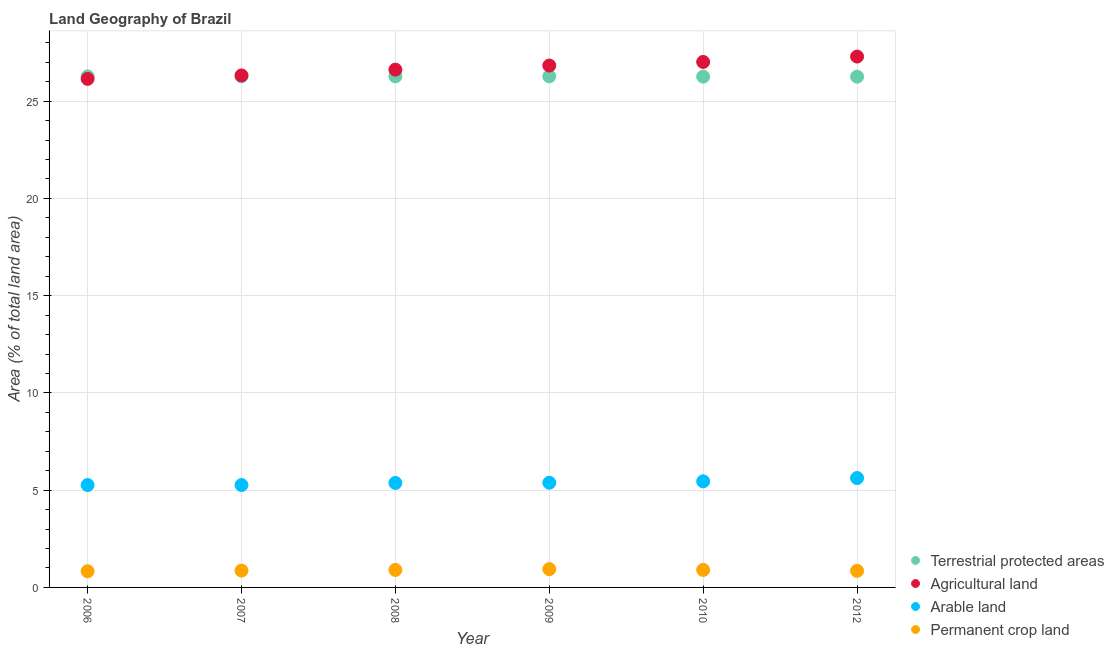How many different coloured dotlines are there?
Your answer should be very brief. 4. Is the number of dotlines equal to the number of legend labels?
Provide a succinct answer. Yes. What is the percentage of area under arable land in 2012?
Give a very brief answer. 5.62. Across all years, what is the maximum percentage of land under terrestrial protection?
Your response must be concise. 26.28. Across all years, what is the minimum percentage of land under terrestrial protection?
Keep it short and to the point. 26.26. What is the total percentage of land under terrestrial protection in the graph?
Offer a very short reply. 157.63. What is the difference between the percentage of area under arable land in 2006 and that in 2010?
Keep it short and to the point. -0.19. What is the difference between the percentage of area under arable land in 2006 and the percentage of area under agricultural land in 2009?
Keep it short and to the point. -21.57. What is the average percentage of land under terrestrial protection per year?
Your answer should be compact. 26.27. In the year 2010, what is the difference between the percentage of area under permanent crop land and percentage of area under agricultural land?
Offer a terse response. -26.12. In how many years, is the percentage of land under terrestrial protection greater than 7 %?
Ensure brevity in your answer.  6. What is the ratio of the percentage of area under arable land in 2007 to that in 2012?
Offer a very short reply. 0.94. Is the percentage of land under terrestrial protection in 2006 less than that in 2009?
Provide a succinct answer. Yes. Is the difference between the percentage of area under agricultural land in 2006 and 2008 greater than the difference between the percentage of area under permanent crop land in 2006 and 2008?
Offer a very short reply. No. What is the difference between the highest and the second highest percentage of area under arable land?
Offer a terse response. 0.17. What is the difference between the highest and the lowest percentage of area under arable land?
Provide a succinct answer. 0.36. In how many years, is the percentage of land under terrestrial protection greater than the average percentage of land under terrestrial protection taken over all years?
Ensure brevity in your answer.  4. Is the percentage of area under arable land strictly greater than the percentage of area under permanent crop land over the years?
Your answer should be very brief. Yes. How many dotlines are there?
Your answer should be compact. 4. How many years are there in the graph?
Make the answer very short. 6. What is the difference between two consecutive major ticks on the Y-axis?
Give a very brief answer. 5. Does the graph contain any zero values?
Your answer should be compact. No. Where does the legend appear in the graph?
Your response must be concise. Bottom right. How are the legend labels stacked?
Offer a very short reply. Vertical. What is the title of the graph?
Your response must be concise. Land Geography of Brazil. Does "Industry" appear as one of the legend labels in the graph?
Your answer should be compact. No. What is the label or title of the X-axis?
Provide a succinct answer. Year. What is the label or title of the Y-axis?
Your answer should be compact. Area (% of total land area). What is the Area (% of total land area) in Terrestrial protected areas in 2006?
Make the answer very short. 26.27. What is the Area (% of total land area) in Agricultural land in 2006?
Your response must be concise. 26.15. What is the Area (% of total land area) of Arable land in 2006?
Provide a succinct answer. 5.26. What is the Area (% of total land area) in Permanent crop land in 2006?
Ensure brevity in your answer.  0.83. What is the Area (% of total land area) in Terrestrial protected areas in 2007?
Your answer should be compact. 26.28. What is the Area (% of total land area) of Agricultural land in 2007?
Give a very brief answer. 26.33. What is the Area (% of total land area) in Arable land in 2007?
Give a very brief answer. 5.26. What is the Area (% of total land area) in Permanent crop land in 2007?
Give a very brief answer. 0.87. What is the Area (% of total land area) in Terrestrial protected areas in 2008?
Provide a short and direct response. 26.28. What is the Area (% of total land area) in Agricultural land in 2008?
Offer a very short reply. 26.62. What is the Area (% of total land area) in Arable land in 2008?
Offer a terse response. 5.37. What is the Area (% of total land area) in Permanent crop land in 2008?
Offer a terse response. 0.9. What is the Area (% of total land area) of Terrestrial protected areas in 2009?
Provide a succinct answer. 26.28. What is the Area (% of total land area) in Agricultural land in 2009?
Ensure brevity in your answer.  26.83. What is the Area (% of total land area) of Arable land in 2009?
Provide a succinct answer. 5.38. What is the Area (% of total land area) in Permanent crop land in 2009?
Make the answer very short. 0.94. What is the Area (% of total land area) in Terrestrial protected areas in 2010?
Give a very brief answer. 26.26. What is the Area (% of total land area) in Agricultural land in 2010?
Your answer should be very brief. 27.02. What is the Area (% of total land area) in Arable land in 2010?
Make the answer very short. 5.46. What is the Area (% of total land area) in Permanent crop land in 2010?
Your answer should be compact. 0.9. What is the Area (% of total land area) of Terrestrial protected areas in 2012?
Your response must be concise. 26.26. What is the Area (% of total land area) of Agricultural land in 2012?
Offer a very short reply. 27.3. What is the Area (% of total land area) in Arable land in 2012?
Make the answer very short. 5.62. What is the Area (% of total land area) in Permanent crop land in 2012?
Offer a very short reply. 0.85. Across all years, what is the maximum Area (% of total land area) in Terrestrial protected areas?
Ensure brevity in your answer.  26.28. Across all years, what is the maximum Area (% of total land area) in Agricultural land?
Ensure brevity in your answer.  27.3. Across all years, what is the maximum Area (% of total land area) of Arable land?
Keep it short and to the point. 5.62. Across all years, what is the maximum Area (% of total land area) in Permanent crop land?
Give a very brief answer. 0.94. Across all years, what is the minimum Area (% of total land area) in Terrestrial protected areas?
Your answer should be compact. 26.26. Across all years, what is the minimum Area (% of total land area) of Agricultural land?
Give a very brief answer. 26.15. Across all years, what is the minimum Area (% of total land area) in Arable land?
Offer a very short reply. 5.26. Across all years, what is the minimum Area (% of total land area) of Permanent crop land?
Offer a terse response. 0.83. What is the total Area (% of total land area) of Terrestrial protected areas in the graph?
Provide a short and direct response. 157.63. What is the total Area (% of total land area) of Agricultural land in the graph?
Keep it short and to the point. 160.24. What is the total Area (% of total land area) of Arable land in the graph?
Offer a very short reply. 32.36. What is the total Area (% of total land area) of Permanent crop land in the graph?
Your answer should be very brief. 5.29. What is the difference between the Area (% of total land area) in Terrestrial protected areas in 2006 and that in 2007?
Ensure brevity in your answer.  -0. What is the difference between the Area (% of total land area) of Agricultural land in 2006 and that in 2007?
Provide a short and direct response. -0.18. What is the difference between the Area (% of total land area) of Permanent crop land in 2006 and that in 2007?
Keep it short and to the point. -0.03. What is the difference between the Area (% of total land area) in Terrestrial protected areas in 2006 and that in 2008?
Keep it short and to the point. -0. What is the difference between the Area (% of total land area) in Agricultural land in 2006 and that in 2008?
Offer a very short reply. -0.47. What is the difference between the Area (% of total land area) of Arable land in 2006 and that in 2008?
Make the answer very short. -0.11. What is the difference between the Area (% of total land area) in Permanent crop land in 2006 and that in 2008?
Your response must be concise. -0.07. What is the difference between the Area (% of total land area) of Terrestrial protected areas in 2006 and that in 2009?
Your answer should be very brief. -0. What is the difference between the Area (% of total land area) in Agricultural land in 2006 and that in 2009?
Your response must be concise. -0.69. What is the difference between the Area (% of total land area) in Arable land in 2006 and that in 2009?
Ensure brevity in your answer.  -0.12. What is the difference between the Area (% of total land area) of Permanent crop land in 2006 and that in 2009?
Your answer should be very brief. -0.11. What is the difference between the Area (% of total land area) of Terrestrial protected areas in 2006 and that in 2010?
Your response must be concise. 0.01. What is the difference between the Area (% of total land area) of Agricultural land in 2006 and that in 2010?
Offer a terse response. -0.87. What is the difference between the Area (% of total land area) in Arable land in 2006 and that in 2010?
Keep it short and to the point. -0.19. What is the difference between the Area (% of total land area) of Permanent crop land in 2006 and that in 2010?
Make the answer very short. -0.07. What is the difference between the Area (% of total land area) of Terrestrial protected areas in 2006 and that in 2012?
Offer a terse response. 0.01. What is the difference between the Area (% of total land area) in Agricultural land in 2006 and that in 2012?
Your response must be concise. -1.15. What is the difference between the Area (% of total land area) of Arable land in 2006 and that in 2012?
Give a very brief answer. -0.36. What is the difference between the Area (% of total land area) of Permanent crop land in 2006 and that in 2012?
Your response must be concise. -0.02. What is the difference between the Area (% of total land area) of Agricultural land in 2007 and that in 2008?
Your response must be concise. -0.3. What is the difference between the Area (% of total land area) in Arable land in 2007 and that in 2008?
Your answer should be compact. -0.11. What is the difference between the Area (% of total land area) of Permanent crop land in 2007 and that in 2008?
Provide a short and direct response. -0.03. What is the difference between the Area (% of total land area) in Agricultural land in 2007 and that in 2009?
Make the answer very short. -0.51. What is the difference between the Area (% of total land area) in Arable land in 2007 and that in 2009?
Your response must be concise. -0.12. What is the difference between the Area (% of total land area) in Permanent crop land in 2007 and that in 2009?
Provide a short and direct response. -0.07. What is the difference between the Area (% of total land area) in Terrestrial protected areas in 2007 and that in 2010?
Give a very brief answer. 0.02. What is the difference between the Area (% of total land area) in Agricultural land in 2007 and that in 2010?
Make the answer very short. -0.69. What is the difference between the Area (% of total land area) in Arable land in 2007 and that in 2010?
Ensure brevity in your answer.  -0.19. What is the difference between the Area (% of total land area) in Permanent crop land in 2007 and that in 2010?
Make the answer very short. -0.03. What is the difference between the Area (% of total land area) of Terrestrial protected areas in 2007 and that in 2012?
Provide a succinct answer. 0.02. What is the difference between the Area (% of total land area) of Agricultural land in 2007 and that in 2012?
Your response must be concise. -0.97. What is the difference between the Area (% of total land area) in Arable land in 2007 and that in 2012?
Offer a terse response. -0.36. What is the difference between the Area (% of total land area) in Permanent crop land in 2007 and that in 2012?
Provide a short and direct response. 0.01. What is the difference between the Area (% of total land area) of Agricultural land in 2008 and that in 2009?
Give a very brief answer. -0.21. What is the difference between the Area (% of total land area) in Arable land in 2008 and that in 2009?
Provide a succinct answer. -0.01. What is the difference between the Area (% of total land area) in Permanent crop land in 2008 and that in 2009?
Make the answer very short. -0.04. What is the difference between the Area (% of total land area) in Terrestrial protected areas in 2008 and that in 2010?
Keep it short and to the point. 0.02. What is the difference between the Area (% of total land area) in Agricultural land in 2008 and that in 2010?
Give a very brief answer. -0.4. What is the difference between the Area (% of total land area) of Arable land in 2008 and that in 2010?
Your response must be concise. -0.08. What is the difference between the Area (% of total land area) of Permanent crop land in 2008 and that in 2010?
Keep it short and to the point. -0. What is the difference between the Area (% of total land area) of Terrestrial protected areas in 2008 and that in 2012?
Provide a succinct answer. 0.02. What is the difference between the Area (% of total land area) in Agricultural land in 2008 and that in 2012?
Your answer should be compact. -0.67. What is the difference between the Area (% of total land area) of Arable land in 2008 and that in 2012?
Ensure brevity in your answer.  -0.25. What is the difference between the Area (% of total land area) in Permanent crop land in 2008 and that in 2012?
Offer a very short reply. 0.05. What is the difference between the Area (% of total land area) of Terrestrial protected areas in 2009 and that in 2010?
Offer a very short reply. 0.02. What is the difference between the Area (% of total land area) in Agricultural land in 2009 and that in 2010?
Keep it short and to the point. -0.18. What is the difference between the Area (% of total land area) of Arable land in 2009 and that in 2010?
Ensure brevity in your answer.  -0.07. What is the difference between the Area (% of total land area) in Permanent crop land in 2009 and that in 2010?
Your response must be concise. 0.04. What is the difference between the Area (% of total land area) of Terrestrial protected areas in 2009 and that in 2012?
Provide a short and direct response. 0.02. What is the difference between the Area (% of total land area) in Agricultural land in 2009 and that in 2012?
Offer a terse response. -0.46. What is the difference between the Area (% of total land area) of Arable land in 2009 and that in 2012?
Your answer should be compact. -0.24. What is the difference between the Area (% of total land area) in Permanent crop land in 2009 and that in 2012?
Offer a terse response. 0.09. What is the difference between the Area (% of total land area) of Terrestrial protected areas in 2010 and that in 2012?
Your answer should be compact. 0. What is the difference between the Area (% of total land area) of Agricultural land in 2010 and that in 2012?
Provide a short and direct response. -0.28. What is the difference between the Area (% of total land area) of Arable land in 2010 and that in 2012?
Give a very brief answer. -0.17. What is the difference between the Area (% of total land area) in Permanent crop land in 2010 and that in 2012?
Keep it short and to the point. 0.05. What is the difference between the Area (% of total land area) of Terrestrial protected areas in 2006 and the Area (% of total land area) of Agricultural land in 2007?
Your answer should be compact. -0.05. What is the difference between the Area (% of total land area) of Terrestrial protected areas in 2006 and the Area (% of total land area) of Arable land in 2007?
Provide a succinct answer. 21.01. What is the difference between the Area (% of total land area) of Terrestrial protected areas in 2006 and the Area (% of total land area) of Permanent crop land in 2007?
Keep it short and to the point. 25.41. What is the difference between the Area (% of total land area) in Agricultural land in 2006 and the Area (% of total land area) in Arable land in 2007?
Make the answer very short. 20.88. What is the difference between the Area (% of total land area) of Agricultural land in 2006 and the Area (% of total land area) of Permanent crop land in 2007?
Your response must be concise. 25.28. What is the difference between the Area (% of total land area) of Arable land in 2006 and the Area (% of total land area) of Permanent crop land in 2007?
Make the answer very short. 4.4. What is the difference between the Area (% of total land area) in Terrestrial protected areas in 2006 and the Area (% of total land area) in Agricultural land in 2008?
Provide a short and direct response. -0.35. What is the difference between the Area (% of total land area) of Terrestrial protected areas in 2006 and the Area (% of total land area) of Arable land in 2008?
Offer a terse response. 20.9. What is the difference between the Area (% of total land area) of Terrestrial protected areas in 2006 and the Area (% of total land area) of Permanent crop land in 2008?
Offer a terse response. 25.38. What is the difference between the Area (% of total land area) of Agricultural land in 2006 and the Area (% of total land area) of Arable land in 2008?
Provide a succinct answer. 20.78. What is the difference between the Area (% of total land area) of Agricultural land in 2006 and the Area (% of total land area) of Permanent crop land in 2008?
Your response must be concise. 25.25. What is the difference between the Area (% of total land area) of Arable land in 2006 and the Area (% of total land area) of Permanent crop land in 2008?
Ensure brevity in your answer.  4.37. What is the difference between the Area (% of total land area) of Terrestrial protected areas in 2006 and the Area (% of total land area) of Agricultural land in 2009?
Keep it short and to the point. -0.56. What is the difference between the Area (% of total land area) of Terrestrial protected areas in 2006 and the Area (% of total land area) of Arable land in 2009?
Make the answer very short. 20.89. What is the difference between the Area (% of total land area) of Terrestrial protected areas in 2006 and the Area (% of total land area) of Permanent crop land in 2009?
Offer a terse response. 25.33. What is the difference between the Area (% of total land area) of Agricultural land in 2006 and the Area (% of total land area) of Arable land in 2009?
Make the answer very short. 20.76. What is the difference between the Area (% of total land area) of Agricultural land in 2006 and the Area (% of total land area) of Permanent crop land in 2009?
Give a very brief answer. 25.21. What is the difference between the Area (% of total land area) in Arable land in 2006 and the Area (% of total land area) in Permanent crop land in 2009?
Offer a terse response. 4.32. What is the difference between the Area (% of total land area) in Terrestrial protected areas in 2006 and the Area (% of total land area) in Agricultural land in 2010?
Offer a terse response. -0.74. What is the difference between the Area (% of total land area) in Terrestrial protected areas in 2006 and the Area (% of total land area) in Arable land in 2010?
Give a very brief answer. 20.82. What is the difference between the Area (% of total land area) of Terrestrial protected areas in 2006 and the Area (% of total land area) of Permanent crop land in 2010?
Offer a very short reply. 25.37. What is the difference between the Area (% of total land area) in Agricultural land in 2006 and the Area (% of total land area) in Arable land in 2010?
Make the answer very short. 20.69. What is the difference between the Area (% of total land area) of Agricultural land in 2006 and the Area (% of total land area) of Permanent crop land in 2010?
Your response must be concise. 25.25. What is the difference between the Area (% of total land area) of Arable land in 2006 and the Area (% of total land area) of Permanent crop land in 2010?
Keep it short and to the point. 4.36. What is the difference between the Area (% of total land area) in Terrestrial protected areas in 2006 and the Area (% of total land area) in Agricultural land in 2012?
Your answer should be compact. -1.02. What is the difference between the Area (% of total land area) of Terrestrial protected areas in 2006 and the Area (% of total land area) of Arable land in 2012?
Offer a very short reply. 20.65. What is the difference between the Area (% of total land area) in Terrestrial protected areas in 2006 and the Area (% of total land area) in Permanent crop land in 2012?
Ensure brevity in your answer.  25.42. What is the difference between the Area (% of total land area) of Agricultural land in 2006 and the Area (% of total land area) of Arable land in 2012?
Ensure brevity in your answer.  20.52. What is the difference between the Area (% of total land area) of Agricultural land in 2006 and the Area (% of total land area) of Permanent crop land in 2012?
Make the answer very short. 25.29. What is the difference between the Area (% of total land area) in Arable land in 2006 and the Area (% of total land area) in Permanent crop land in 2012?
Keep it short and to the point. 4.41. What is the difference between the Area (% of total land area) of Terrestrial protected areas in 2007 and the Area (% of total land area) of Agricultural land in 2008?
Make the answer very short. -0.34. What is the difference between the Area (% of total land area) of Terrestrial protected areas in 2007 and the Area (% of total land area) of Arable land in 2008?
Provide a short and direct response. 20.91. What is the difference between the Area (% of total land area) in Terrestrial protected areas in 2007 and the Area (% of total land area) in Permanent crop land in 2008?
Keep it short and to the point. 25.38. What is the difference between the Area (% of total land area) in Agricultural land in 2007 and the Area (% of total land area) in Arable land in 2008?
Ensure brevity in your answer.  20.95. What is the difference between the Area (% of total land area) of Agricultural land in 2007 and the Area (% of total land area) of Permanent crop land in 2008?
Provide a short and direct response. 25.43. What is the difference between the Area (% of total land area) in Arable land in 2007 and the Area (% of total land area) in Permanent crop land in 2008?
Your answer should be very brief. 4.37. What is the difference between the Area (% of total land area) of Terrestrial protected areas in 2007 and the Area (% of total land area) of Agricultural land in 2009?
Provide a succinct answer. -0.56. What is the difference between the Area (% of total land area) in Terrestrial protected areas in 2007 and the Area (% of total land area) in Arable land in 2009?
Your answer should be very brief. 20.89. What is the difference between the Area (% of total land area) in Terrestrial protected areas in 2007 and the Area (% of total land area) in Permanent crop land in 2009?
Ensure brevity in your answer.  25.34. What is the difference between the Area (% of total land area) in Agricultural land in 2007 and the Area (% of total land area) in Arable land in 2009?
Provide a short and direct response. 20.94. What is the difference between the Area (% of total land area) in Agricultural land in 2007 and the Area (% of total land area) in Permanent crop land in 2009?
Provide a succinct answer. 25.39. What is the difference between the Area (% of total land area) of Arable land in 2007 and the Area (% of total land area) of Permanent crop land in 2009?
Your answer should be compact. 4.32. What is the difference between the Area (% of total land area) of Terrestrial protected areas in 2007 and the Area (% of total land area) of Agricultural land in 2010?
Your response must be concise. -0.74. What is the difference between the Area (% of total land area) of Terrestrial protected areas in 2007 and the Area (% of total land area) of Arable land in 2010?
Make the answer very short. 20.82. What is the difference between the Area (% of total land area) of Terrestrial protected areas in 2007 and the Area (% of total land area) of Permanent crop land in 2010?
Provide a succinct answer. 25.38. What is the difference between the Area (% of total land area) of Agricultural land in 2007 and the Area (% of total land area) of Arable land in 2010?
Your answer should be compact. 20.87. What is the difference between the Area (% of total land area) of Agricultural land in 2007 and the Area (% of total land area) of Permanent crop land in 2010?
Ensure brevity in your answer.  25.43. What is the difference between the Area (% of total land area) in Arable land in 2007 and the Area (% of total land area) in Permanent crop land in 2010?
Ensure brevity in your answer.  4.36. What is the difference between the Area (% of total land area) of Terrestrial protected areas in 2007 and the Area (% of total land area) of Agricultural land in 2012?
Offer a terse response. -1.02. What is the difference between the Area (% of total land area) in Terrestrial protected areas in 2007 and the Area (% of total land area) in Arable land in 2012?
Your answer should be very brief. 20.66. What is the difference between the Area (% of total land area) of Terrestrial protected areas in 2007 and the Area (% of total land area) of Permanent crop land in 2012?
Provide a short and direct response. 25.42. What is the difference between the Area (% of total land area) in Agricultural land in 2007 and the Area (% of total land area) in Arable land in 2012?
Your answer should be compact. 20.7. What is the difference between the Area (% of total land area) of Agricultural land in 2007 and the Area (% of total land area) of Permanent crop land in 2012?
Give a very brief answer. 25.47. What is the difference between the Area (% of total land area) of Arable land in 2007 and the Area (% of total land area) of Permanent crop land in 2012?
Offer a terse response. 4.41. What is the difference between the Area (% of total land area) in Terrestrial protected areas in 2008 and the Area (% of total land area) in Agricultural land in 2009?
Offer a very short reply. -0.56. What is the difference between the Area (% of total land area) in Terrestrial protected areas in 2008 and the Area (% of total land area) in Arable land in 2009?
Make the answer very short. 20.89. What is the difference between the Area (% of total land area) of Terrestrial protected areas in 2008 and the Area (% of total land area) of Permanent crop land in 2009?
Your answer should be compact. 25.34. What is the difference between the Area (% of total land area) in Agricultural land in 2008 and the Area (% of total land area) in Arable land in 2009?
Your answer should be compact. 21.24. What is the difference between the Area (% of total land area) in Agricultural land in 2008 and the Area (% of total land area) in Permanent crop land in 2009?
Ensure brevity in your answer.  25.68. What is the difference between the Area (% of total land area) of Arable land in 2008 and the Area (% of total land area) of Permanent crop land in 2009?
Offer a terse response. 4.43. What is the difference between the Area (% of total land area) of Terrestrial protected areas in 2008 and the Area (% of total land area) of Agricultural land in 2010?
Provide a succinct answer. -0.74. What is the difference between the Area (% of total land area) in Terrestrial protected areas in 2008 and the Area (% of total land area) in Arable land in 2010?
Keep it short and to the point. 20.82. What is the difference between the Area (% of total land area) of Terrestrial protected areas in 2008 and the Area (% of total land area) of Permanent crop land in 2010?
Ensure brevity in your answer.  25.38. What is the difference between the Area (% of total land area) in Agricultural land in 2008 and the Area (% of total land area) in Arable land in 2010?
Give a very brief answer. 21.17. What is the difference between the Area (% of total land area) of Agricultural land in 2008 and the Area (% of total land area) of Permanent crop land in 2010?
Your response must be concise. 25.72. What is the difference between the Area (% of total land area) of Arable land in 2008 and the Area (% of total land area) of Permanent crop land in 2010?
Make the answer very short. 4.47. What is the difference between the Area (% of total land area) in Terrestrial protected areas in 2008 and the Area (% of total land area) in Agricultural land in 2012?
Your answer should be very brief. -1.02. What is the difference between the Area (% of total land area) of Terrestrial protected areas in 2008 and the Area (% of total land area) of Arable land in 2012?
Your response must be concise. 20.66. What is the difference between the Area (% of total land area) in Terrestrial protected areas in 2008 and the Area (% of total land area) in Permanent crop land in 2012?
Provide a short and direct response. 25.42. What is the difference between the Area (% of total land area) in Agricultural land in 2008 and the Area (% of total land area) in Arable land in 2012?
Ensure brevity in your answer.  21. What is the difference between the Area (% of total land area) in Agricultural land in 2008 and the Area (% of total land area) in Permanent crop land in 2012?
Provide a short and direct response. 25.77. What is the difference between the Area (% of total land area) in Arable land in 2008 and the Area (% of total land area) in Permanent crop land in 2012?
Offer a terse response. 4.52. What is the difference between the Area (% of total land area) in Terrestrial protected areas in 2009 and the Area (% of total land area) in Agricultural land in 2010?
Your answer should be very brief. -0.74. What is the difference between the Area (% of total land area) of Terrestrial protected areas in 2009 and the Area (% of total land area) of Arable land in 2010?
Make the answer very short. 20.82. What is the difference between the Area (% of total land area) of Terrestrial protected areas in 2009 and the Area (% of total land area) of Permanent crop land in 2010?
Provide a succinct answer. 25.38. What is the difference between the Area (% of total land area) of Agricultural land in 2009 and the Area (% of total land area) of Arable land in 2010?
Give a very brief answer. 21.38. What is the difference between the Area (% of total land area) of Agricultural land in 2009 and the Area (% of total land area) of Permanent crop land in 2010?
Your answer should be very brief. 25.93. What is the difference between the Area (% of total land area) of Arable land in 2009 and the Area (% of total land area) of Permanent crop land in 2010?
Your answer should be compact. 4.48. What is the difference between the Area (% of total land area) in Terrestrial protected areas in 2009 and the Area (% of total land area) in Agricultural land in 2012?
Offer a terse response. -1.02. What is the difference between the Area (% of total land area) in Terrestrial protected areas in 2009 and the Area (% of total land area) in Arable land in 2012?
Your answer should be very brief. 20.66. What is the difference between the Area (% of total land area) in Terrestrial protected areas in 2009 and the Area (% of total land area) in Permanent crop land in 2012?
Provide a short and direct response. 25.42. What is the difference between the Area (% of total land area) of Agricultural land in 2009 and the Area (% of total land area) of Arable land in 2012?
Give a very brief answer. 21.21. What is the difference between the Area (% of total land area) in Agricultural land in 2009 and the Area (% of total land area) in Permanent crop land in 2012?
Offer a terse response. 25.98. What is the difference between the Area (% of total land area) in Arable land in 2009 and the Area (% of total land area) in Permanent crop land in 2012?
Ensure brevity in your answer.  4.53. What is the difference between the Area (% of total land area) in Terrestrial protected areas in 2010 and the Area (% of total land area) in Agricultural land in 2012?
Give a very brief answer. -1.03. What is the difference between the Area (% of total land area) of Terrestrial protected areas in 2010 and the Area (% of total land area) of Arable land in 2012?
Provide a short and direct response. 20.64. What is the difference between the Area (% of total land area) of Terrestrial protected areas in 2010 and the Area (% of total land area) of Permanent crop land in 2012?
Give a very brief answer. 25.41. What is the difference between the Area (% of total land area) of Agricultural land in 2010 and the Area (% of total land area) of Arable land in 2012?
Ensure brevity in your answer.  21.4. What is the difference between the Area (% of total land area) in Agricultural land in 2010 and the Area (% of total land area) in Permanent crop land in 2012?
Provide a short and direct response. 26.16. What is the difference between the Area (% of total land area) in Arable land in 2010 and the Area (% of total land area) in Permanent crop land in 2012?
Your answer should be compact. 4.6. What is the average Area (% of total land area) in Terrestrial protected areas per year?
Provide a succinct answer. 26.27. What is the average Area (% of total land area) of Agricultural land per year?
Make the answer very short. 26.71. What is the average Area (% of total land area) of Arable land per year?
Give a very brief answer. 5.39. What is the average Area (% of total land area) in Permanent crop land per year?
Offer a very short reply. 0.88. In the year 2006, what is the difference between the Area (% of total land area) in Terrestrial protected areas and Area (% of total land area) in Agricultural land?
Make the answer very short. 0.13. In the year 2006, what is the difference between the Area (% of total land area) in Terrestrial protected areas and Area (% of total land area) in Arable land?
Keep it short and to the point. 21.01. In the year 2006, what is the difference between the Area (% of total land area) of Terrestrial protected areas and Area (% of total land area) of Permanent crop land?
Make the answer very short. 25.44. In the year 2006, what is the difference between the Area (% of total land area) in Agricultural land and Area (% of total land area) in Arable land?
Offer a terse response. 20.88. In the year 2006, what is the difference between the Area (% of total land area) of Agricultural land and Area (% of total land area) of Permanent crop land?
Give a very brief answer. 25.32. In the year 2006, what is the difference between the Area (% of total land area) of Arable land and Area (% of total land area) of Permanent crop land?
Make the answer very short. 4.43. In the year 2007, what is the difference between the Area (% of total land area) of Terrestrial protected areas and Area (% of total land area) of Agricultural land?
Keep it short and to the point. -0.05. In the year 2007, what is the difference between the Area (% of total land area) in Terrestrial protected areas and Area (% of total land area) in Arable land?
Your answer should be very brief. 21.01. In the year 2007, what is the difference between the Area (% of total land area) of Terrestrial protected areas and Area (% of total land area) of Permanent crop land?
Offer a very short reply. 25.41. In the year 2007, what is the difference between the Area (% of total land area) in Agricultural land and Area (% of total land area) in Arable land?
Offer a terse response. 21.06. In the year 2007, what is the difference between the Area (% of total land area) of Agricultural land and Area (% of total land area) of Permanent crop land?
Make the answer very short. 25.46. In the year 2007, what is the difference between the Area (% of total land area) in Arable land and Area (% of total land area) in Permanent crop land?
Offer a terse response. 4.4. In the year 2008, what is the difference between the Area (% of total land area) in Terrestrial protected areas and Area (% of total land area) in Agricultural land?
Your response must be concise. -0.34. In the year 2008, what is the difference between the Area (% of total land area) in Terrestrial protected areas and Area (% of total land area) in Arable land?
Your answer should be very brief. 20.91. In the year 2008, what is the difference between the Area (% of total land area) of Terrestrial protected areas and Area (% of total land area) of Permanent crop land?
Your answer should be compact. 25.38. In the year 2008, what is the difference between the Area (% of total land area) of Agricultural land and Area (% of total land area) of Arable land?
Make the answer very short. 21.25. In the year 2008, what is the difference between the Area (% of total land area) in Agricultural land and Area (% of total land area) in Permanent crop land?
Keep it short and to the point. 25.72. In the year 2008, what is the difference between the Area (% of total land area) in Arable land and Area (% of total land area) in Permanent crop land?
Keep it short and to the point. 4.47. In the year 2009, what is the difference between the Area (% of total land area) of Terrestrial protected areas and Area (% of total land area) of Agricultural land?
Make the answer very short. -0.55. In the year 2009, what is the difference between the Area (% of total land area) of Terrestrial protected areas and Area (% of total land area) of Arable land?
Offer a very short reply. 20.89. In the year 2009, what is the difference between the Area (% of total land area) in Terrestrial protected areas and Area (% of total land area) in Permanent crop land?
Provide a short and direct response. 25.34. In the year 2009, what is the difference between the Area (% of total land area) in Agricultural land and Area (% of total land area) in Arable land?
Your response must be concise. 21.45. In the year 2009, what is the difference between the Area (% of total land area) in Agricultural land and Area (% of total land area) in Permanent crop land?
Your answer should be very brief. 25.89. In the year 2009, what is the difference between the Area (% of total land area) in Arable land and Area (% of total land area) in Permanent crop land?
Provide a succinct answer. 4.44. In the year 2010, what is the difference between the Area (% of total land area) in Terrestrial protected areas and Area (% of total land area) in Agricultural land?
Your answer should be compact. -0.76. In the year 2010, what is the difference between the Area (% of total land area) in Terrestrial protected areas and Area (% of total land area) in Arable land?
Provide a succinct answer. 20.81. In the year 2010, what is the difference between the Area (% of total land area) of Terrestrial protected areas and Area (% of total land area) of Permanent crop land?
Your response must be concise. 25.36. In the year 2010, what is the difference between the Area (% of total land area) of Agricultural land and Area (% of total land area) of Arable land?
Your answer should be very brief. 21.56. In the year 2010, what is the difference between the Area (% of total land area) of Agricultural land and Area (% of total land area) of Permanent crop land?
Your response must be concise. 26.12. In the year 2010, what is the difference between the Area (% of total land area) of Arable land and Area (% of total land area) of Permanent crop land?
Offer a very short reply. 4.56. In the year 2012, what is the difference between the Area (% of total land area) of Terrestrial protected areas and Area (% of total land area) of Agricultural land?
Offer a terse response. -1.03. In the year 2012, what is the difference between the Area (% of total land area) in Terrestrial protected areas and Area (% of total land area) in Arable land?
Give a very brief answer. 20.64. In the year 2012, what is the difference between the Area (% of total land area) in Terrestrial protected areas and Area (% of total land area) in Permanent crop land?
Provide a succinct answer. 25.41. In the year 2012, what is the difference between the Area (% of total land area) in Agricultural land and Area (% of total land area) in Arable land?
Your answer should be compact. 21.67. In the year 2012, what is the difference between the Area (% of total land area) in Agricultural land and Area (% of total land area) in Permanent crop land?
Provide a succinct answer. 26.44. In the year 2012, what is the difference between the Area (% of total land area) in Arable land and Area (% of total land area) in Permanent crop land?
Your answer should be very brief. 4.77. What is the ratio of the Area (% of total land area) of Agricultural land in 2006 to that in 2007?
Offer a terse response. 0.99. What is the ratio of the Area (% of total land area) in Arable land in 2006 to that in 2007?
Provide a short and direct response. 1. What is the ratio of the Area (% of total land area) of Permanent crop land in 2006 to that in 2007?
Keep it short and to the point. 0.96. What is the ratio of the Area (% of total land area) of Agricultural land in 2006 to that in 2008?
Your answer should be compact. 0.98. What is the ratio of the Area (% of total land area) in Permanent crop land in 2006 to that in 2008?
Offer a very short reply. 0.93. What is the ratio of the Area (% of total land area) of Terrestrial protected areas in 2006 to that in 2009?
Ensure brevity in your answer.  1. What is the ratio of the Area (% of total land area) of Agricultural land in 2006 to that in 2009?
Provide a succinct answer. 0.97. What is the ratio of the Area (% of total land area) in Arable land in 2006 to that in 2009?
Provide a short and direct response. 0.98. What is the ratio of the Area (% of total land area) in Permanent crop land in 2006 to that in 2009?
Provide a short and direct response. 0.88. What is the ratio of the Area (% of total land area) in Agricultural land in 2006 to that in 2010?
Your answer should be very brief. 0.97. What is the ratio of the Area (% of total land area) in Arable land in 2006 to that in 2010?
Your answer should be compact. 0.96. What is the ratio of the Area (% of total land area) of Permanent crop land in 2006 to that in 2010?
Offer a very short reply. 0.92. What is the ratio of the Area (% of total land area) of Terrestrial protected areas in 2006 to that in 2012?
Give a very brief answer. 1. What is the ratio of the Area (% of total land area) of Agricultural land in 2006 to that in 2012?
Make the answer very short. 0.96. What is the ratio of the Area (% of total land area) in Arable land in 2006 to that in 2012?
Provide a succinct answer. 0.94. What is the ratio of the Area (% of total land area) of Permanent crop land in 2006 to that in 2012?
Offer a terse response. 0.97. What is the ratio of the Area (% of total land area) of Terrestrial protected areas in 2007 to that in 2008?
Make the answer very short. 1. What is the ratio of the Area (% of total land area) in Agricultural land in 2007 to that in 2008?
Ensure brevity in your answer.  0.99. What is the ratio of the Area (% of total land area) in Permanent crop land in 2007 to that in 2008?
Provide a short and direct response. 0.96. What is the ratio of the Area (% of total land area) in Agricultural land in 2007 to that in 2009?
Make the answer very short. 0.98. What is the ratio of the Area (% of total land area) in Arable land in 2007 to that in 2009?
Keep it short and to the point. 0.98. What is the ratio of the Area (% of total land area) of Permanent crop land in 2007 to that in 2009?
Offer a very short reply. 0.92. What is the ratio of the Area (% of total land area) in Agricultural land in 2007 to that in 2010?
Your response must be concise. 0.97. What is the ratio of the Area (% of total land area) in Arable land in 2007 to that in 2010?
Offer a very short reply. 0.96. What is the ratio of the Area (% of total land area) in Permanent crop land in 2007 to that in 2010?
Provide a succinct answer. 0.96. What is the ratio of the Area (% of total land area) of Agricultural land in 2007 to that in 2012?
Make the answer very short. 0.96. What is the ratio of the Area (% of total land area) in Arable land in 2007 to that in 2012?
Your response must be concise. 0.94. What is the ratio of the Area (% of total land area) in Permanent crop land in 2007 to that in 2012?
Provide a short and direct response. 1.01. What is the ratio of the Area (% of total land area) of Terrestrial protected areas in 2008 to that in 2009?
Provide a short and direct response. 1. What is the ratio of the Area (% of total land area) in Permanent crop land in 2008 to that in 2009?
Your response must be concise. 0.96. What is the ratio of the Area (% of total land area) of Arable land in 2008 to that in 2010?
Offer a very short reply. 0.98. What is the ratio of the Area (% of total land area) of Permanent crop land in 2008 to that in 2010?
Provide a short and direct response. 1. What is the ratio of the Area (% of total land area) in Agricultural land in 2008 to that in 2012?
Ensure brevity in your answer.  0.98. What is the ratio of the Area (% of total land area) in Arable land in 2008 to that in 2012?
Provide a succinct answer. 0.96. What is the ratio of the Area (% of total land area) in Permanent crop land in 2008 to that in 2012?
Your answer should be compact. 1.05. What is the ratio of the Area (% of total land area) of Arable land in 2009 to that in 2010?
Offer a terse response. 0.99. What is the ratio of the Area (% of total land area) of Permanent crop land in 2009 to that in 2010?
Provide a succinct answer. 1.05. What is the ratio of the Area (% of total land area) in Terrestrial protected areas in 2009 to that in 2012?
Keep it short and to the point. 1. What is the ratio of the Area (% of total land area) in Agricultural land in 2009 to that in 2012?
Keep it short and to the point. 0.98. What is the ratio of the Area (% of total land area) of Arable land in 2009 to that in 2012?
Offer a very short reply. 0.96. What is the ratio of the Area (% of total land area) of Permanent crop land in 2009 to that in 2012?
Make the answer very short. 1.1. What is the ratio of the Area (% of total land area) of Terrestrial protected areas in 2010 to that in 2012?
Offer a terse response. 1. What is the ratio of the Area (% of total land area) in Agricultural land in 2010 to that in 2012?
Give a very brief answer. 0.99. What is the ratio of the Area (% of total land area) of Arable land in 2010 to that in 2012?
Your response must be concise. 0.97. What is the ratio of the Area (% of total land area) in Permanent crop land in 2010 to that in 2012?
Offer a terse response. 1.05. What is the difference between the highest and the second highest Area (% of total land area) in Terrestrial protected areas?
Provide a short and direct response. 0. What is the difference between the highest and the second highest Area (% of total land area) in Agricultural land?
Your answer should be compact. 0.28. What is the difference between the highest and the second highest Area (% of total land area) in Arable land?
Offer a very short reply. 0.17. What is the difference between the highest and the second highest Area (% of total land area) of Permanent crop land?
Provide a short and direct response. 0.04. What is the difference between the highest and the lowest Area (% of total land area) of Terrestrial protected areas?
Offer a terse response. 0.02. What is the difference between the highest and the lowest Area (% of total land area) of Agricultural land?
Your answer should be very brief. 1.15. What is the difference between the highest and the lowest Area (% of total land area) of Arable land?
Your response must be concise. 0.36. What is the difference between the highest and the lowest Area (% of total land area) of Permanent crop land?
Your answer should be very brief. 0.11. 